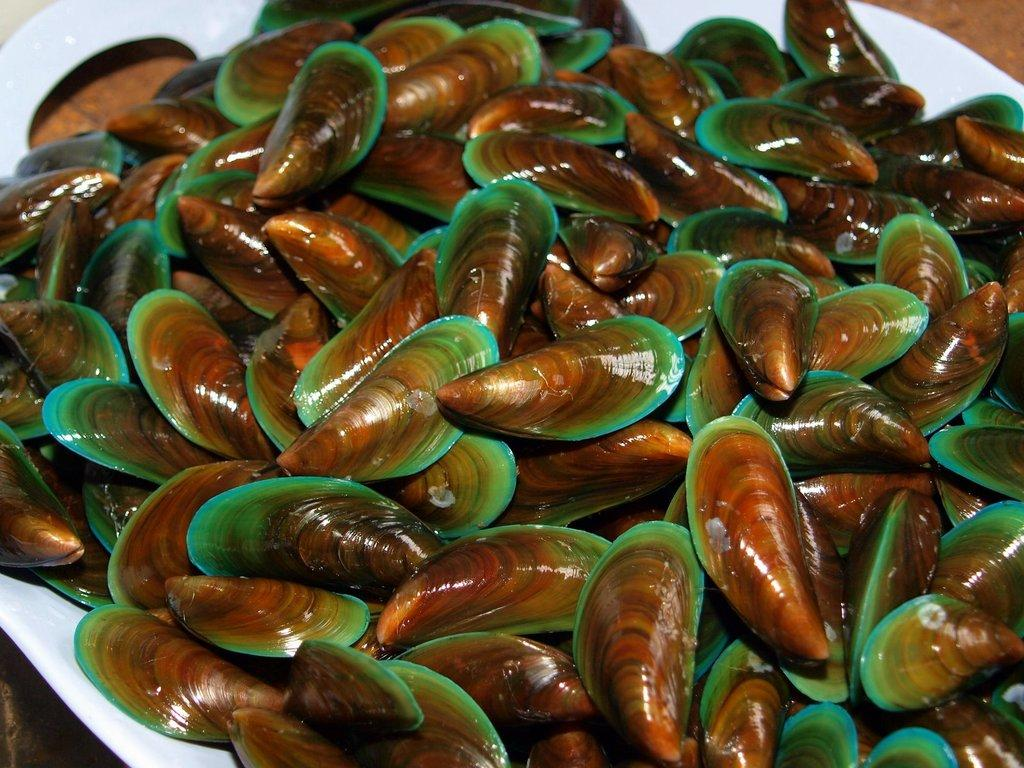What type of clothing item is in the image? There are red thongs in the image. Where are the red thongs located? The red thongs are on a plate. What type of canvas is visible in the image? There is no canvas present in the image. Can you describe the detail of the kiss in the image? There is no kiss present in the image. 